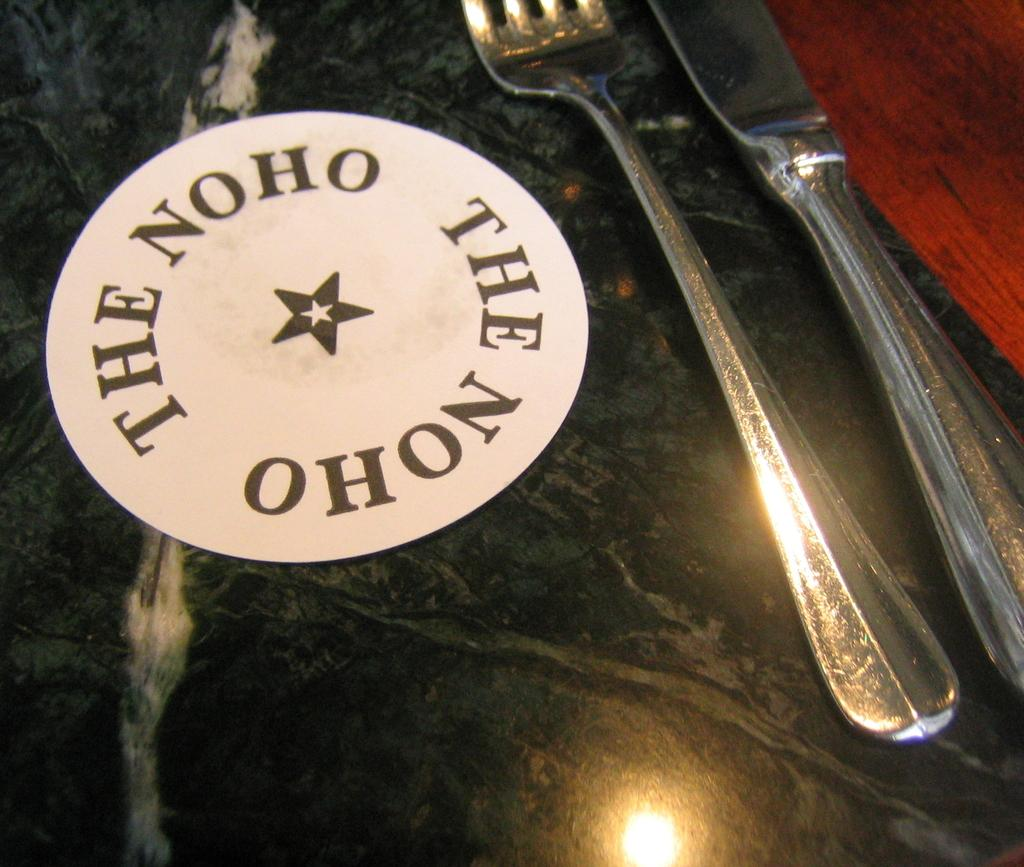What colors are present on the surface in the image? The surface in the image has a black and red color. What can be seen on the surface besides the colors? There is writing on the surface. What utensils are visible on the right side of the image? There is a fork and a knife on the right side of the image. What type of silver material can be seen on the floor in the image? There is no silver material or floor present in the image; it only features a surface with writing and utensils. 